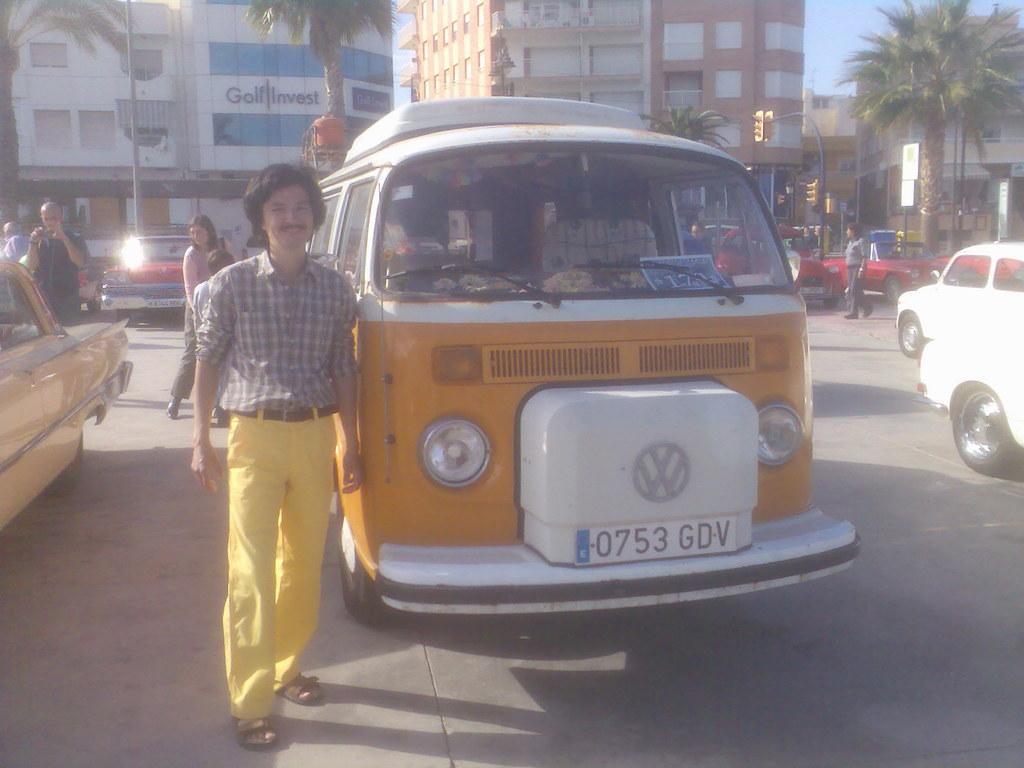Could you give a brief overview of what you see in this image? In this image there are so many vehicles on the road and there are a few people standing and walking on the road. In the background there are buildings, poles, trees, boards with some text and the sky. 